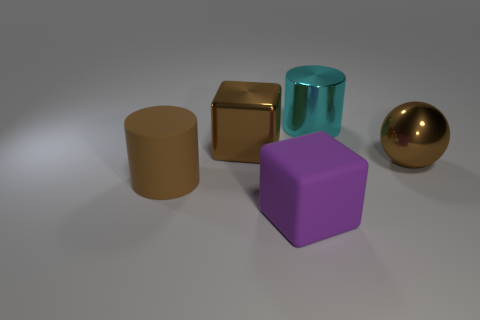There is a rubber object that is on the left side of the big metal block; is it the same color as the large thing on the right side of the cyan object?
Keep it short and to the point. Yes. How many matte objects are in front of the rubber cylinder?
Make the answer very short. 1. Are there any metallic things that have the same shape as the big purple rubber object?
Ensure brevity in your answer.  Yes. What is the color of the shiny block that is the same size as the metallic sphere?
Your answer should be very brief. Brown. Is the number of large metallic things right of the purple matte object less than the number of big things left of the metal cylinder?
Offer a very short reply. Yes. The big brown metallic thing behind the ball has what shape?
Provide a succinct answer. Cube. Is the number of big metallic balls greater than the number of small yellow metallic spheres?
Provide a succinct answer. Yes. There is a large cylinder left of the cyan shiny thing; is its color the same as the shiny ball?
Offer a very short reply. Yes. How many things are either large blocks that are behind the big purple thing or metal objects that are right of the brown block?
Make the answer very short. 3. What number of things are both on the left side of the big purple rubber cube and in front of the large brown metallic sphere?
Your response must be concise. 1. 